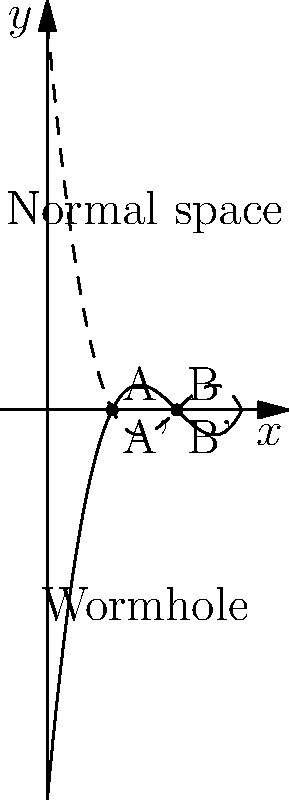In your science fiction movie, you want to illustrate wormhole navigation using warped coordinate systems. The graph shows a representation of normal space (solid curve) and a wormhole (dashed curve). Points A and B in normal space correspond to A' and B' in the wormhole. If the distance between A and B in normal space is 5 light-years, and the distance between A' and B' through the wormhole is 1 light-year, what is the time saved (in years) by traveling through the wormhole if the spacecraft moves at 0.5c (half the speed of light)? To solve this problem, we need to follow these steps:

1. Calculate the time taken to travel in normal space:
   - Distance in normal space = 5 light-years
   - Speed of spacecraft = 0.5c
   - Time = Distance / Speed
   - Time in normal space = 5 / (0.5c) = 10 years

2. Calculate the time taken to travel through the wormhole:
   - Distance through wormhole = 1 light-year
   - Speed of spacecraft = 0.5c
   - Time = Distance / Speed
   - Time through wormhole = 1 / (0.5c) = 2 years

3. Calculate the time saved:
   - Time saved = Time in normal space - Time through wormhole
   - Time saved = 10 years - 2 years = 8 years

Therefore, by traveling through the wormhole, the spacecraft saves 8 years compared to traveling through normal space.
Answer: 8 years 